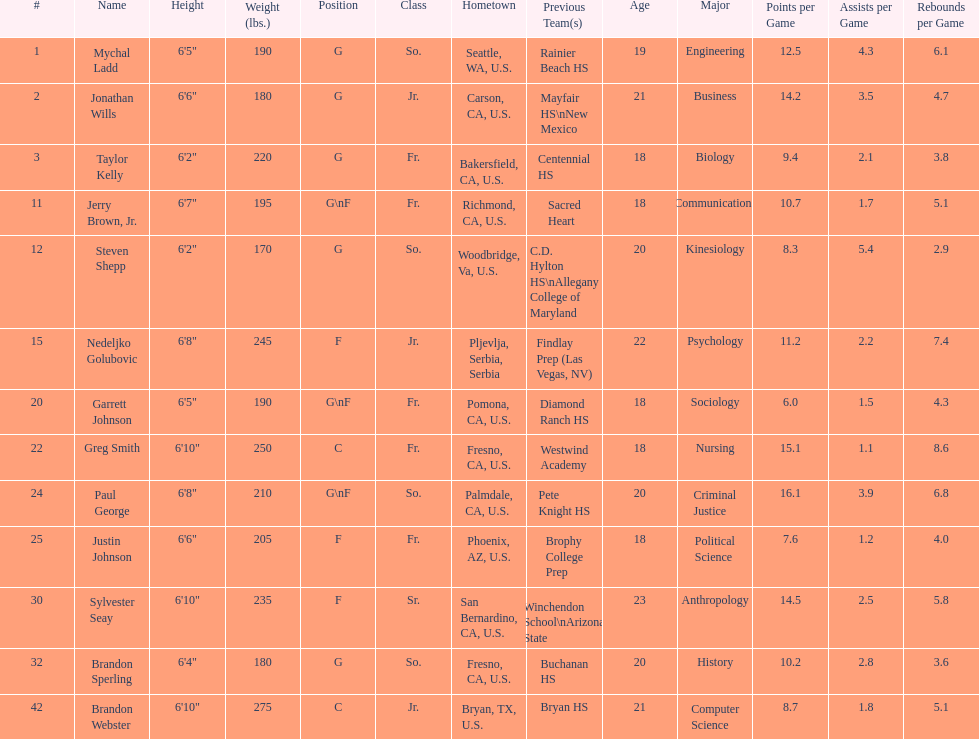What is the number of players who weight over 200 pounds? 7. Parse the table in full. {'header': ['#', 'Name', 'Height', 'Weight (lbs.)', 'Position', 'Class', 'Hometown', 'Previous Team(s)', 'Age', 'Major', 'Points per Game', 'Assists per Game', 'Rebounds per Game'], 'rows': [['1', 'Mychal Ladd', '6\'5"', '190', 'G', 'So.', 'Seattle, WA, U.S.', 'Rainier Beach HS', '19', 'Engineering', '12.5', '4.3', '6.1'], ['2', 'Jonathan Wills', '6\'6"', '180', 'G', 'Jr.', 'Carson, CA, U.S.', 'Mayfair HS\\nNew Mexico', '21', 'Business', '14.2', '3.5', '4.7'], ['3', 'Taylor Kelly', '6\'2"', '220', 'G', 'Fr.', 'Bakersfield, CA, U.S.', 'Centennial HS', '18', 'Biology', '9.4', '2.1', '3.8'], ['11', 'Jerry Brown, Jr.', '6\'7"', '195', 'G\\nF', 'Fr.', 'Richmond, CA, U.S.', 'Sacred Heart', '18', 'Communications', '10.7', '1.7', '5.1'], ['12', 'Steven Shepp', '6\'2"', '170', 'G', 'So.', 'Woodbridge, Va, U.S.', 'C.D. Hylton HS\\nAllegany College of Maryland', '20', 'Kinesiology', '8.3', '5.4', '2.9'], ['15', 'Nedeljko Golubovic', '6\'8"', '245', 'F', 'Jr.', 'Pljevlja, Serbia, Serbia', 'Findlay Prep (Las Vegas, NV)', '22', 'Psychology', '11.2', '2.2', '7.4'], ['20', 'Garrett Johnson', '6\'5"', '190', 'G\\nF', 'Fr.', 'Pomona, CA, U.S.', 'Diamond Ranch HS', '18', 'Sociology', '6.0', '1.5', '4.3'], ['22', 'Greg Smith', '6\'10"', '250', 'C', 'Fr.', 'Fresno, CA, U.S.', 'Westwind Academy', '18', 'Nursing', '15.1', '1.1', '8.6'], ['24', 'Paul George', '6\'8"', '210', 'G\\nF', 'So.', 'Palmdale, CA, U.S.', 'Pete Knight HS', '20', 'Criminal Justice', '16.1', '3.9', '6.8'], ['25', 'Justin Johnson', '6\'6"', '205', 'F', 'Fr.', 'Phoenix, AZ, U.S.', 'Brophy College Prep', '18', 'Political Science', '7.6', '1.2', '4.0'], ['30', 'Sylvester Seay', '6\'10"', '235', 'F', 'Sr.', 'San Bernardino, CA, U.S.', 'Winchendon School\\nArizona State', '23', 'Anthropology', '14.5', '2.5', '5.8'], ['32', 'Brandon Sperling', '6\'4"', '180', 'G', 'So.', 'Fresno, CA, U.S.', 'Buchanan HS', '20', 'History', '10.2', '2.8', '3.6'], ['42', 'Brandon Webster', '6\'10"', '275', 'C', 'Jr.', 'Bryan, TX, U.S.', 'Bryan HS', '21', 'Computer Science', '8.7', '1.8', '5.1']]} 